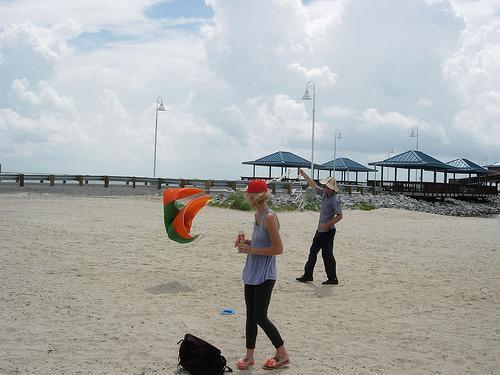How many people are in the photo?
Give a very brief answer. 2. 